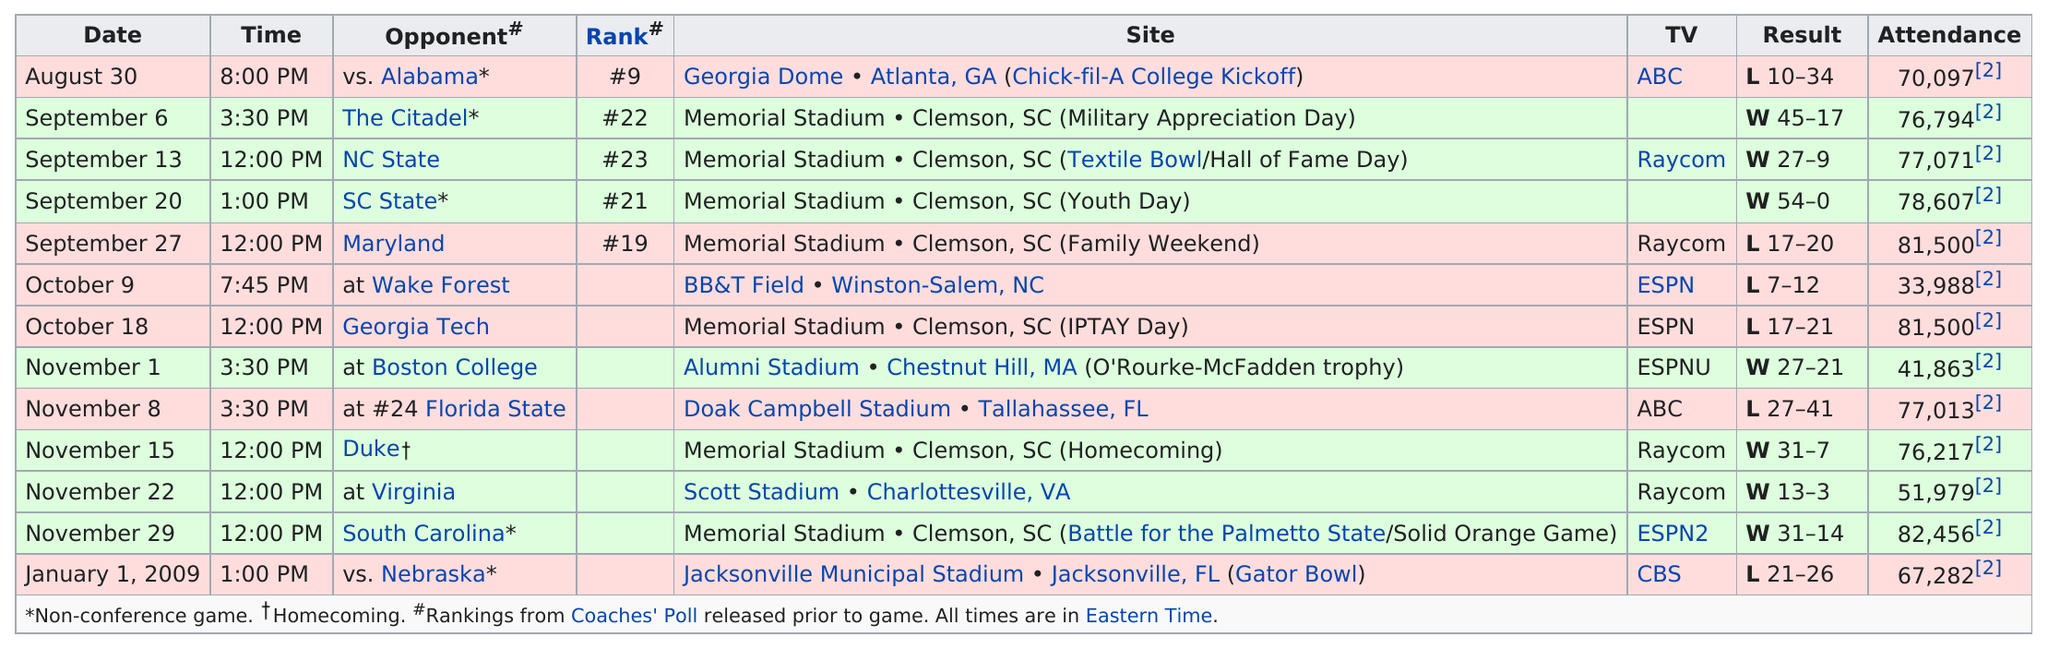Highlight a few significant elements in this photo. The date that was attended by the most people was November 29th. On their first win of the 2008 season, the tigers faced The Citadel. The tigers faced the Citadel after their game against Alabama in 2008 Of the 7 dates, 5 resulted in a letter other than 'l'. In the 2008 season, the Tigers lost a total of 6 games. 